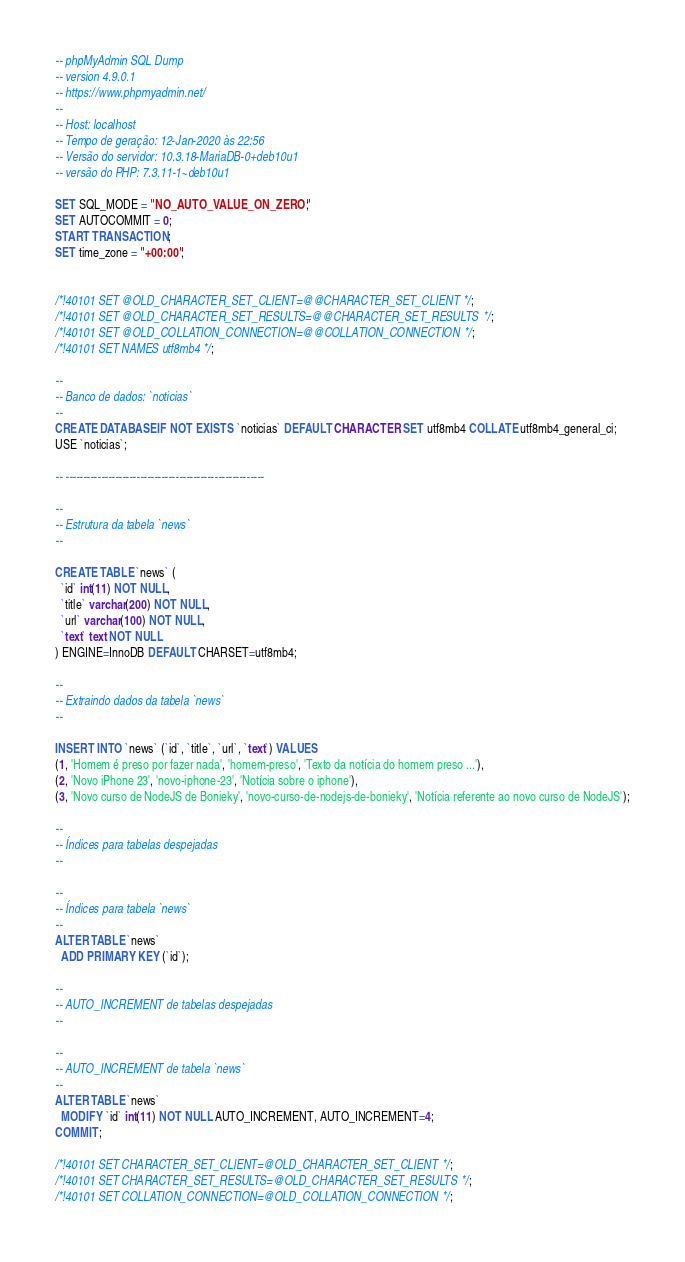<code> <loc_0><loc_0><loc_500><loc_500><_SQL_>-- phpMyAdmin SQL Dump
-- version 4.9.0.1
-- https://www.phpmyadmin.net/
--
-- Host: localhost
-- Tempo de geração: 12-Jan-2020 às 22:56
-- Versão do servidor: 10.3.18-MariaDB-0+deb10u1
-- versão do PHP: 7.3.11-1~deb10u1

SET SQL_MODE = "NO_AUTO_VALUE_ON_ZERO";
SET AUTOCOMMIT = 0;
START TRANSACTION;
SET time_zone = "+00:00";


/*!40101 SET @OLD_CHARACTER_SET_CLIENT=@@CHARACTER_SET_CLIENT */;
/*!40101 SET @OLD_CHARACTER_SET_RESULTS=@@CHARACTER_SET_RESULTS */;
/*!40101 SET @OLD_COLLATION_CONNECTION=@@COLLATION_CONNECTION */;
/*!40101 SET NAMES utf8mb4 */;

--
-- Banco de dados: `noticias`
--
CREATE DATABASE IF NOT EXISTS `noticias` DEFAULT CHARACTER SET utf8mb4 COLLATE utf8mb4_general_ci;
USE `noticias`;

-- --------------------------------------------------------

--
-- Estrutura da tabela `news`
--

CREATE TABLE `news` (
  `id` int(11) NOT NULL,
  `title` varchar(200) NOT NULL,
  `url` varchar(100) NOT NULL,
  `text` text NOT NULL
) ENGINE=InnoDB DEFAULT CHARSET=utf8mb4;

--
-- Extraindo dados da tabela `news`
--

INSERT INTO `news` (`id`, `title`, `url`, `text`) VALUES
(1, 'Homem é preso por fazer nada', 'homem-preso', 'Texto da notícia do homem preso ...'),
(2, 'Novo iPhone 23', 'novo-iphone-23', 'Notícia sobre o iphone'),
(3, 'Novo curso de NodeJS de Bonieky', 'novo-curso-de-nodejs-de-bonieky', 'Notícia referente ao novo curso de NodeJS');

--
-- Índices para tabelas despejadas
--

--
-- Índices para tabela `news`
--
ALTER TABLE `news`
  ADD PRIMARY KEY (`id`);

--
-- AUTO_INCREMENT de tabelas despejadas
--

--
-- AUTO_INCREMENT de tabela `news`
--
ALTER TABLE `news`
  MODIFY `id` int(11) NOT NULL AUTO_INCREMENT, AUTO_INCREMENT=4;
COMMIT;

/*!40101 SET CHARACTER_SET_CLIENT=@OLD_CHARACTER_SET_CLIENT */;
/*!40101 SET CHARACTER_SET_RESULTS=@OLD_CHARACTER_SET_RESULTS */;
/*!40101 SET COLLATION_CONNECTION=@OLD_COLLATION_CONNECTION */;
</code> 